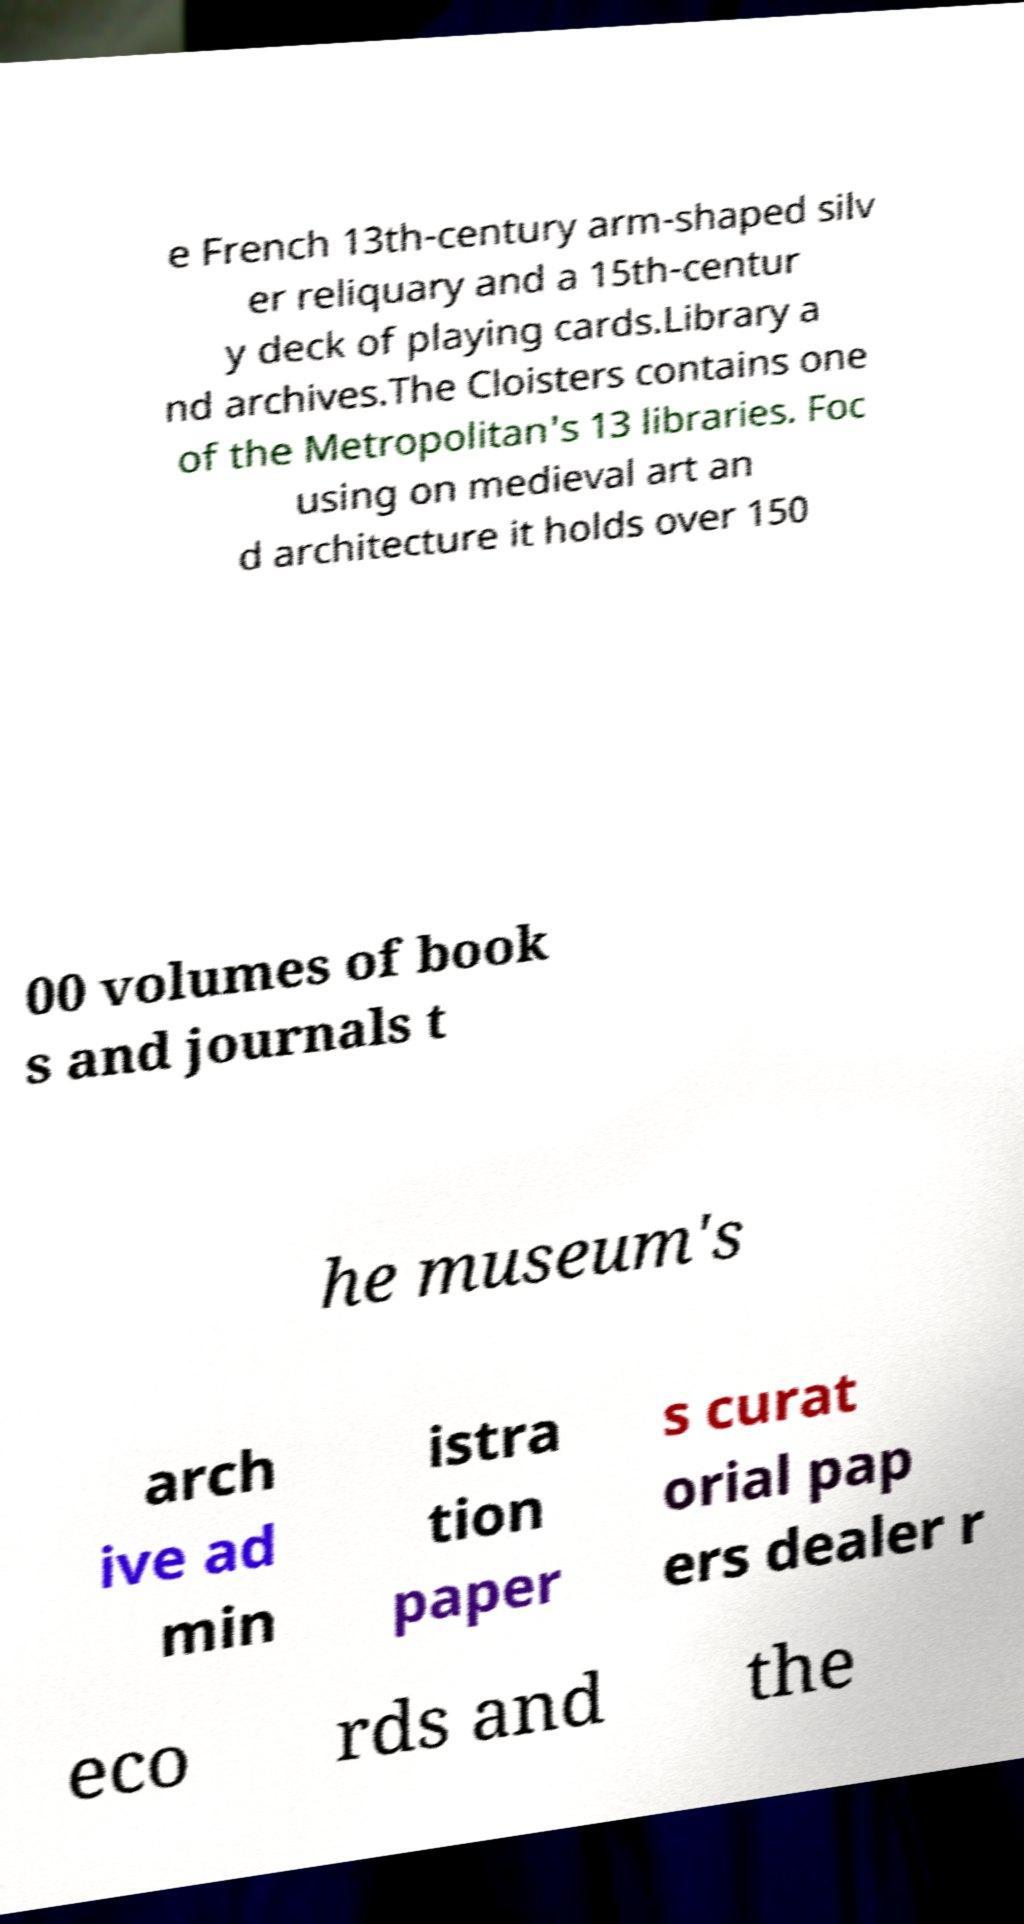Can you read and provide the text displayed in the image?This photo seems to have some interesting text. Can you extract and type it out for me? e French 13th-century arm-shaped silv er reliquary and a 15th-centur y deck of playing cards.Library a nd archives.The Cloisters contains one of the Metropolitan's 13 libraries. Foc using on medieval art an d architecture it holds over 150 00 volumes of book s and journals t he museum's arch ive ad min istra tion paper s curat orial pap ers dealer r eco rds and the 